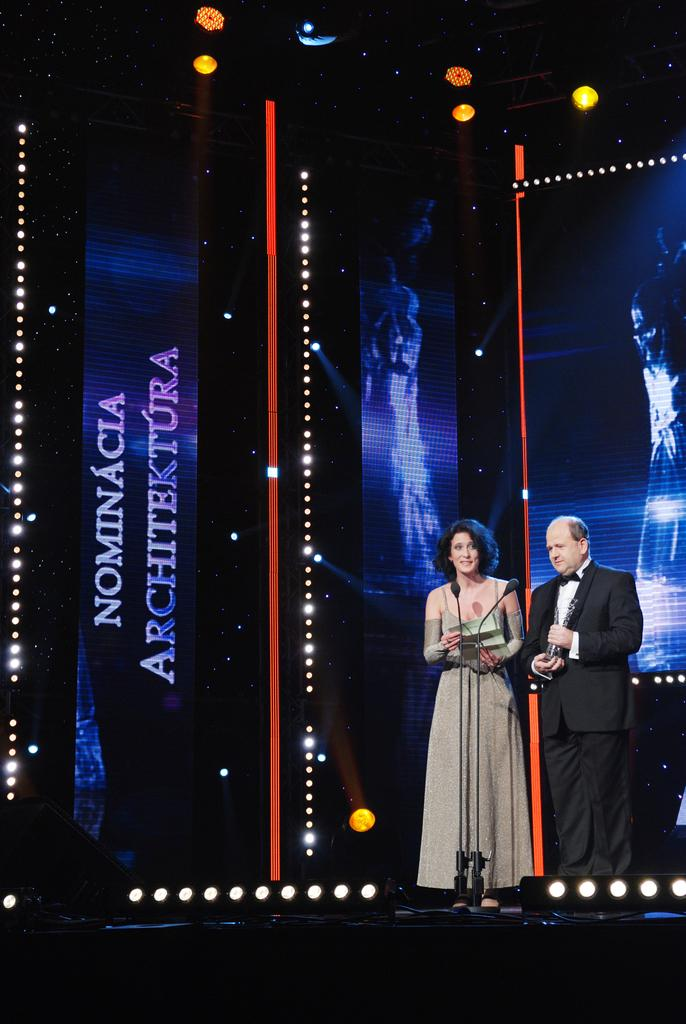How many people are on the stage in the image? There are two people standing on the stage in the image. What can be seen in the background of the image? There is a screen in the background of the image. What is used for amplifying sound in the image? There is a mic present in the image. What type of lighting is visible in the image? There are lights visible at the top of the image. What type of chicken is being used as a prop on the stage? There is no chicken present in the image; it features two people on a stage with a screen, a mic, and lights. 